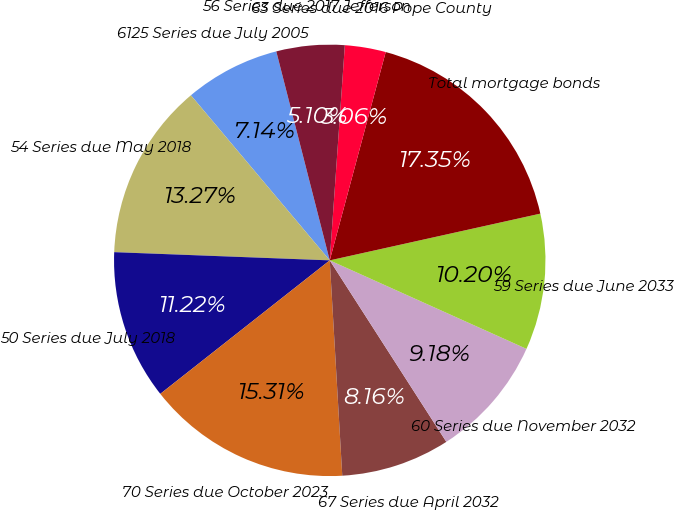Convert chart. <chart><loc_0><loc_0><loc_500><loc_500><pie_chart><fcel>6125 Series due July 2005<fcel>54 Series due May 2018<fcel>50 Series due July 2018<fcel>70 Series due October 2023<fcel>67 Series due April 2032<fcel>60 Series due November 2032<fcel>59 Series due June 2033<fcel>Total mortgage bonds<fcel>63 Series due 2016 Pope County<fcel>56 Series due 2017 Jefferson<nl><fcel>7.14%<fcel>13.26%<fcel>11.22%<fcel>15.3%<fcel>8.16%<fcel>9.18%<fcel>10.2%<fcel>17.34%<fcel>3.06%<fcel>5.1%<nl></chart> 